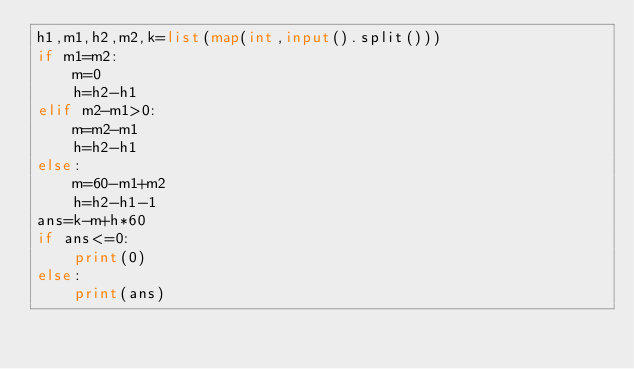Convert code to text. <code><loc_0><loc_0><loc_500><loc_500><_Python_>h1,m1,h2,m2,k=list(map(int,input().split()))
if m1=m2:
    m=0
    h=h2-h1
elif m2-m1>0:
    m=m2-m1
    h=h2-h1
else:
    m=60-m1+m2
    h=h2-h1-1
ans=k-m+h*60
if ans<=0:
    print(0)
else:
    print(ans)

</code> 